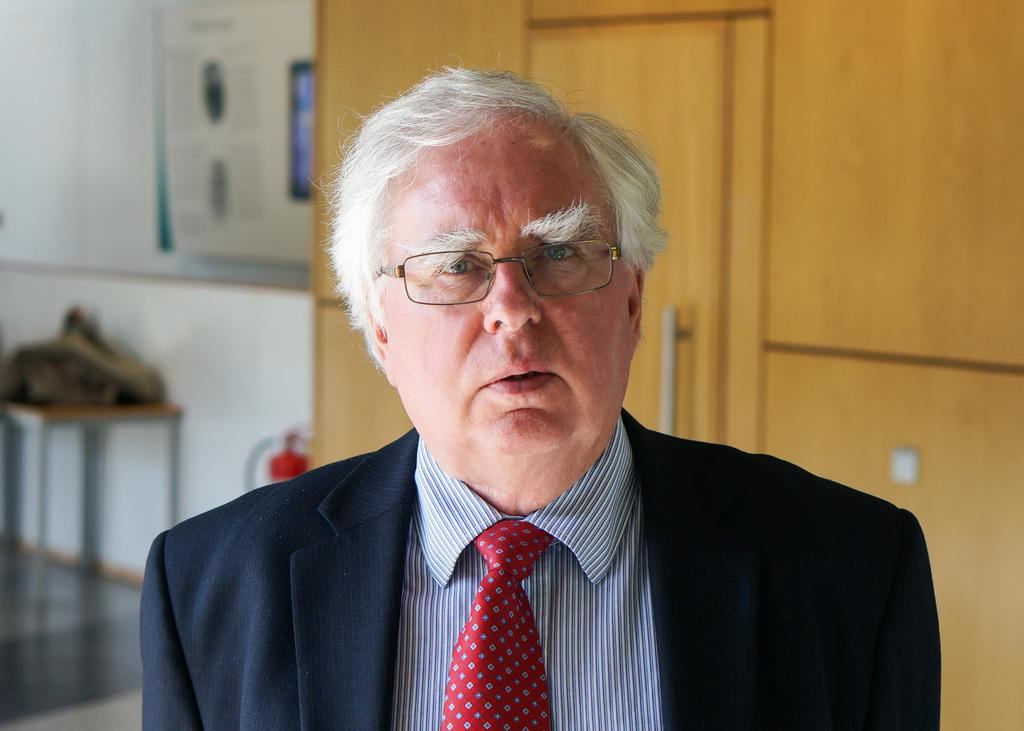What is the man in the image wearing? The man is wearing a suit. What can be seen in the background of the image? There is a door and a bench in the image. What is on the bench? There is an object on the bench. Is there any safety equipment visible in the image? Yes, there is a fire extinguisher in the image. What type of disease is the man suffering from in the image? There is no indication in the image that the man is suffering from any disease. How does the wind affect the man's suit in the image? There is no wind present in the image, so it cannot affect the man's suit. 